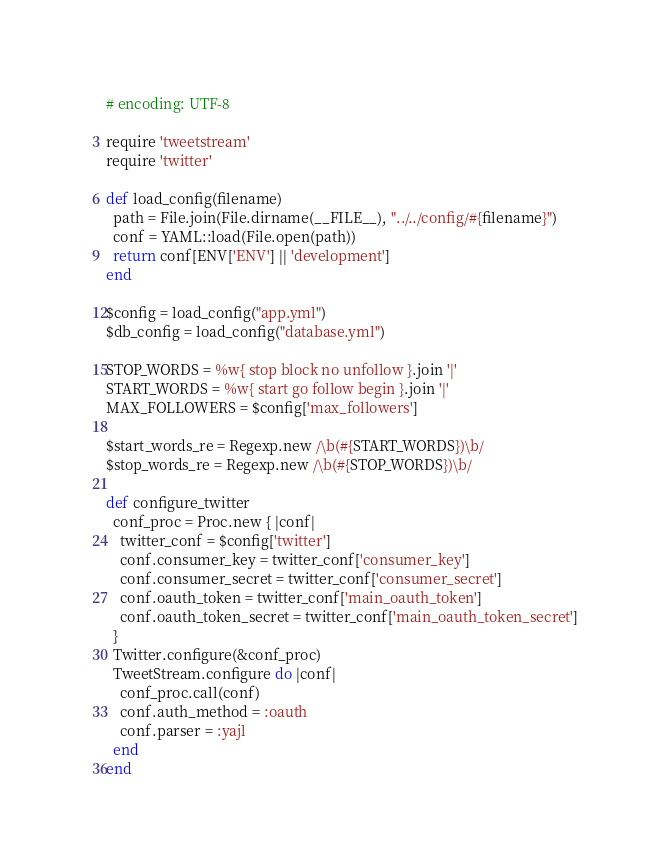<code> <loc_0><loc_0><loc_500><loc_500><_Ruby_># encoding: UTF-8

require 'tweetstream'
require 'twitter'

def load_config(filename)
  path = File.join(File.dirname(__FILE__), "../../config/#{filename}")
  conf = YAML::load(File.open(path))
  return conf[ENV['ENV'] || 'development']
end

$config = load_config("app.yml")
$db_config = load_config("database.yml")

STOP_WORDS = %w{ stop block no unfollow }.join '|'
START_WORDS = %w{ start go follow begin }.join '|'
MAX_FOLLOWERS = $config['max_followers']

$start_words_re = Regexp.new /\b(#{START_WORDS})\b/
$stop_words_re = Regexp.new /\b(#{STOP_WORDS})\b/

def configure_twitter
  conf_proc = Proc.new { |conf|
    twitter_conf = $config['twitter']
    conf.consumer_key = twitter_conf['consumer_key']
    conf.consumer_secret = twitter_conf['consumer_secret']
    conf.oauth_token = twitter_conf['main_oauth_token']
    conf.oauth_token_secret = twitter_conf['main_oauth_token_secret']
  }
  Twitter.configure(&conf_proc)
  TweetStream.configure do |conf|
    conf_proc.call(conf)
    conf.auth_method = :oauth
    conf.parser = :yajl
  end
end
</code> 